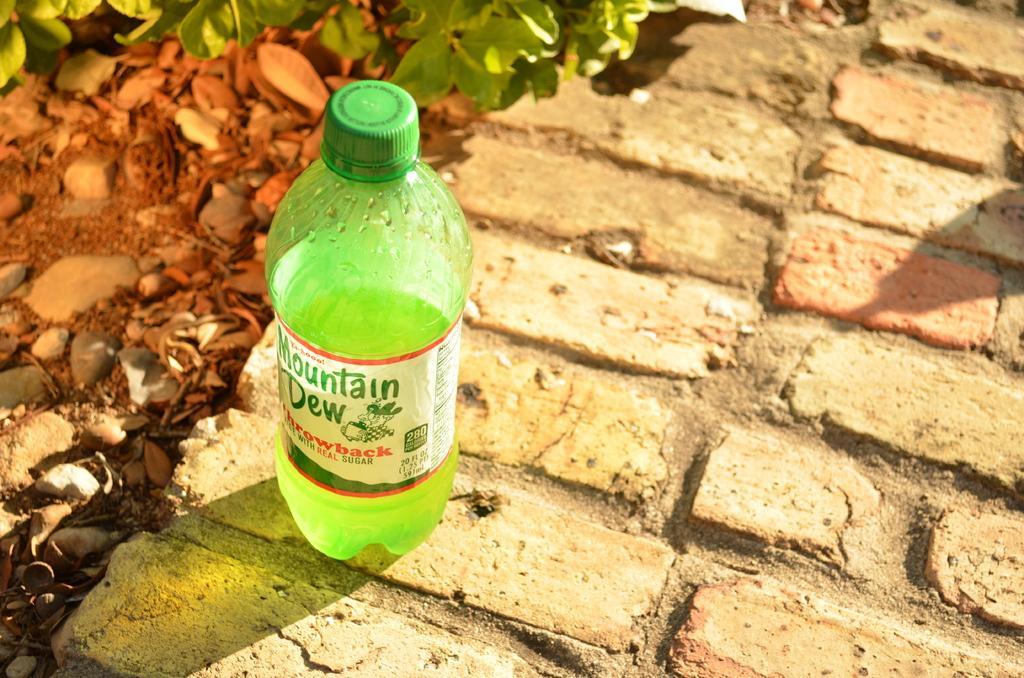Please provide a concise description of this image. In the picture there is a bottle with a liquid on it there is a label with the text on the bottle the bottle is on the floor there are plants near the bottle there are also some stones near to the bottle. 